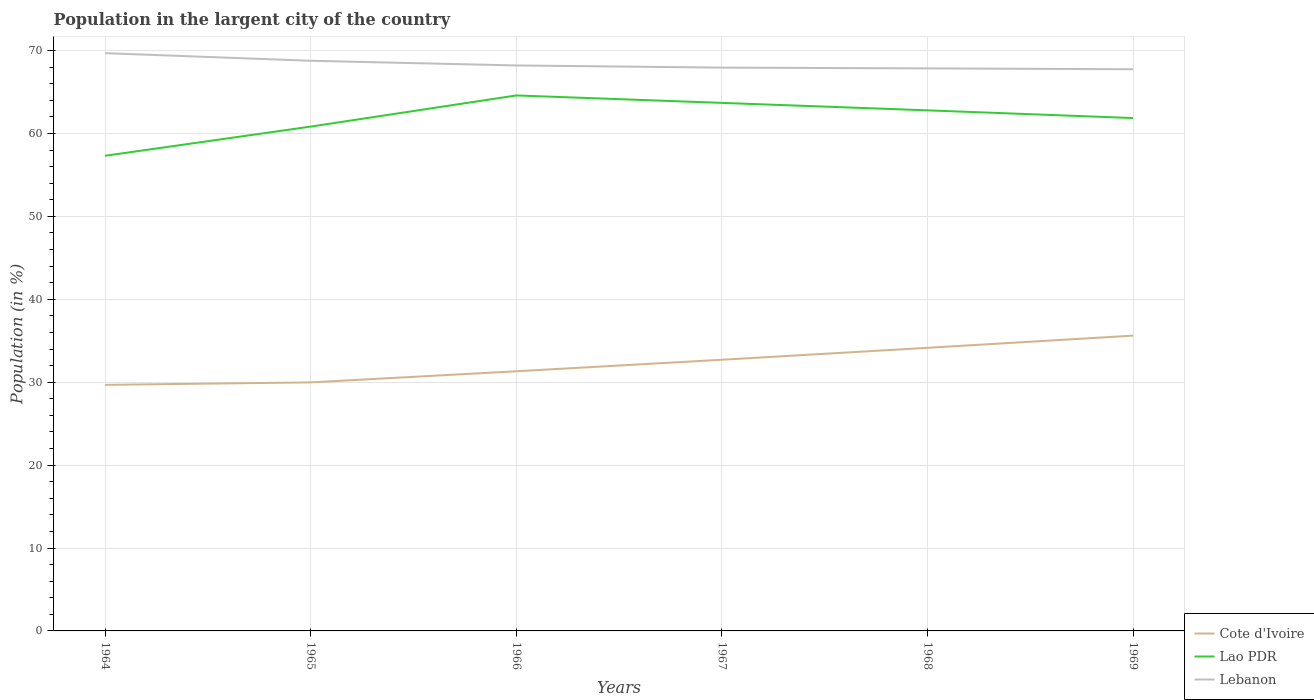Across all years, what is the maximum percentage of population in the largent city in Cote d'Ivoire?
Your answer should be compact. 29.68. In which year was the percentage of population in the largent city in Lebanon maximum?
Your answer should be compact. 1969. What is the total percentage of population in the largent city in Lao PDR in the graph?
Keep it short and to the point. -1.03. What is the difference between the highest and the second highest percentage of population in the largent city in Lao PDR?
Keep it short and to the point. 7.28. Is the percentage of population in the largent city in Lebanon strictly greater than the percentage of population in the largent city in Lao PDR over the years?
Offer a terse response. No. How many lines are there?
Your response must be concise. 3. How many years are there in the graph?
Make the answer very short. 6. Are the values on the major ticks of Y-axis written in scientific E-notation?
Your answer should be compact. No. How are the legend labels stacked?
Your answer should be very brief. Vertical. What is the title of the graph?
Your answer should be very brief. Population in the largent city of the country. What is the label or title of the X-axis?
Provide a succinct answer. Years. What is the label or title of the Y-axis?
Your answer should be very brief. Population (in %). What is the Population (in %) in Cote d'Ivoire in 1964?
Provide a short and direct response. 29.68. What is the Population (in %) of Lao PDR in 1964?
Your answer should be very brief. 57.31. What is the Population (in %) of Lebanon in 1964?
Keep it short and to the point. 69.69. What is the Population (in %) in Cote d'Ivoire in 1965?
Your answer should be very brief. 29.98. What is the Population (in %) in Lao PDR in 1965?
Provide a succinct answer. 60.84. What is the Population (in %) in Lebanon in 1965?
Your answer should be compact. 68.77. What is the Population (in %) of Cote d'Ivoire in 1966?
Offer a terse response. 31.32. What is the Population (in %) of Lao PDR in 1966?
Your answer should be compact. 64.59. What is the Population (in %) of Lebanon in 1966?
Provide a succinct answer. 68.21. What is the Population (in %) in Cote d'Ivoire in 1967?
Your answer should be compact. 32.71. What is the Population (in %) of Lao PDR in 1967?
Your answer should be compact. 63.69. What is the Population (in %) in Lebanon in 1967?
Offer a very short reply. 67.95. What is the Population (in %) of Cote d'Ivoire in 1968?
Offer a very short reply. 34.15. What is the Population (in %) of Lao PDR in 1968?
Provide a short and direct response. 62.79. What is the Population (in %) in Lebanon in 1968?
Give a very brief answer. 67.86. What is the Population (in %) in Cote d'Ivoire in 1969?
Provide a short and direct response. 35.62. What is the Population (in %) in Lao PDR in 1969?
Offer a very short reply. 61.86. What is the Population (in %) of Lebanon in 1969?
Ensure brevity in your answer.  67.75. Across all years, what is the maximum Population (in %) of Cote d'Ivoire?
Ensure brevity in your answer.  35.62. Across all years, what is the maximum Population (in %) in Lao PDR?
Provide a succinct answer. 64.59. Across all years, what is the maximum Population (in %) in Lebanon?
Your response must be concise. 69.69. Across all years, what is the minimum Population (in %) in Cote d'Ivoire?
Your answer should be very brief. 29.68. Across all years, what is the minimum Population (in %) in Lao PDR?
Make the answer very short. 57.31. Across all years, what is the minimum Population (in %) of Lebanon?
Your answer should be very brief. 67.75. What is the total Population (in %) in Cote d'Ivoire in the graph?
Your response must be concise. 193.46. What is the total Population (in %) in Lao PDR in the graph?
Give a very brief answer. 371.1. What is the total Population (in %) in Lebanon in the graph?
Ensure brevity in your answer.  410.23. What is the difference between the Population (in %) of Cote d'Ivoire in 1964 and that in 1965?
Provide a succinct answer. -0.3. What is the difference between the Population (in %) in Lao PDR in 1964 and that in 1965?
Keep it short and to the point. -3.52. What is the difference between the Population (in %) of Lebanon in 1964 and that in 1965?
Your answer should be compact. 0.92. What is the difference between the Population (in %) of Cote d'Ivoire in 1964 and that in 1966?
Offer a very short reply. -1.64. What is the difference between the Population (in %) in Lao PDR in 1964 and that in 1966?
Provide a short and direct response. -7.28. What is the difference between the Population (in %) in Lebanon in 1964 and that in 1966?
Your answer should be very brief. 1.48. What is the difference between the Population (in %) of Cote d'Ivoire in 1964 and that in 1967?
Offer a terse response. -3.03. What is the difference between the Population (in %) in Lao PDR in 1964 and that in 1967?
Your answer should be very brief. -6.38. What is the difference between the Population (in %) of Lebanon in 1964 and that in 1967?
Offer a very short reply. 1.74. What is the difference between the Population (in %) in Cote d'Ivoire in 1964 and that in 1968?
Provide a short and direct response. -4.47. What is the difference between the Population (in %) of Lao PDR in 1964 and that in 1968?
Your answer should be very brief. -5.48. What is the difference between the Population (in %) in Lebanon in 1964 and that in 1968?
Give a very brief answer. 1.84. What is the difference between the Population (in %) in Cote d'Ivoire in 1964 and that in 1969?
Make the answer very short. -5.94. What is the difference between the Population (in %) of Lao PDR in 1964 and that in 1969?
Your answer should be compact. -4.55. What is the difference between the Population (in %) of Lebanon in 1964 and that in 1969?
Provide a short and direct response. 1.94. What is the difference between the Population (in %) in Cote d'Ivoire in 1965 and that in 1966?
Give a very brief answer. -1.34. What is the difference between the Population (in %) in Lao PDR in 1965 and that in 1966?
Give a very brief answer. -3.76. What is the difference between the Population (in %) in Lebanon in 1965 and that in 1966?
Make the answer very short. 0.57. What is the difference between the Population (in %) of Cote d'Ivoire in 1965 and that in 1967?
Your answer should be compact. -2.73. What is the difference between the Population (in %) in Lao PDR in 1965 and that in 1967?
Your answer should be compact. -2.86. What is the difference between the Population (in %) of Lebanon in 1965 and that in 1967?
Your answer should be compact. 0.83. What is the difference between the Population (in %) in Cote d'Ivoire in 1965 and that in 1968?
Ensure brevity in your answer.  -4.17. What is the difference between the Population (in %) in Lao PDR in 1965 and that in 1968?
Offer a terse response. -1.96. What is the difference between the Population (in %) in Lebanon in 1965 and that in 1968?
Make the answer very short. 0.92. What is the difference between the Population (in %) in Cote d'Ivoire in 1965 and that in 1969?
Give a very brief answer. -5.64. What is the difference between the Population (in %) in Lao PDR in 1965 and that in 1969?
Keep it short and to the point. -1.03. What is the difference between the Population (in %) in Lebanon in 1965 and that in 1969?
Your answer should be compact. 1.02. What is the difference between the Population (in %) of Cote d'Ivoire in 1966 and that in 1967?
Your answer should be very brief. -1.39. What is the difference between the Population (in %) in Lao PDR in 1966 and that in 1967?
Provide a short and direct response. 0.9. What is the difference between the Population (in %) in Lebanon in 1966 and that in 1967?
Your answer should be compact. 0.26. What is the difference between the Population (in %) of Cote d'Ivoire in 1966 and that in 1968?
Give a very brief answer. -2.83. What is the difference between the Population (in %) of Lao PDR in 1966 and that in 1968?
Your response must be concise. 1.8. What is the difference between the Population (in %) in Lebanon in 1966 and that in 1968?
Make the answer very short. 0.35. What is the difference between the Population (in %) of Cote d'Ivoire in 1966 and that in 1969?
Provide a succinct answer. -4.3. What is the difference between the Population (in %) in Lao PDR in 1966 and that in 1969?
Offer a terse response. 2.73. What is the difference between the Population (in %) in Lebanon in 1966 and that in 1969?
Give a very brief answer. 0.46. What is the difference between the Population (in %) in Cote d'Ivoire in 1967 and that in 1968?
Your answer should be very brief. -1.44. What is the difference between the Population (in %) of Lao PDR in 1967 and that in 1968?
Provide a succinct answer. 0.9. What is the difference between the Population (in %) in Lebanon in 1967 and that in 1968?
Offer a terse response. 0.09. What is the difference between the Population (in %) in Cote d'Ivoire in 1967 and that in 1969?
Your answer should be compact. -2.91. What is the difference between the Population (in %) in Lao PDR in 1967 and that in 1969?
Your response must be concise. 1.83. What is the difference between the Population (in %) of Lebanon in 1967 and that in 1969?
Your response must be concise. 0.2. What is the difference between the Population (in %) of Cote d'Ivoire in 1968 and that in 1969?
Your response must be concise. -1.47. What is the difference between the Population (in %) in Lao PDR in 1968 and that in 1969?
Make the answer very short. 0.93. What is the difference between the Population (in %) in Lebanon in 1968 and that in 1969?
Offer a terse response. 0.1. What is the difference between the Population (in %) in Cote d'Ivoire in 1964 and the Population (in %) in Lao PDR in 1965?
Your response must be concise. -31.15. What is the difference between the Population (in %) in Cote d'Ivoire in 1964 and the Population (in %) in Lebanon in 1965?
Your response must be concise. -39.09. What is the difference between the Population (in %) of Lao PDR in 1964 and the Population (in %) of Lebanon in 1965?
Provide a succinct answer. -11.46. What is the difference between the Population (in %) of Cote d'Ivoire in 1964 and the Population (in %) of Lao PDR in 1966?
Ensure brevity in your answer.  -34.91. What is the difference between the Population (in %) of Cote d'Ivoire in 1964 and the Population (in %) of Lebanon in 1966?
Your answer should be compact. -38.53. What is the difference between the Population (in %) in Lao PDR in 1964 and the Population (in %) in Lebanon in 1966?
Your answer should be compact. -10.9. What is the difference between the Population (in %) of Cote d'Ivoire in 1964 and the Population (in %) of Lao PDR in 1967?
Your answer should be very brief. -34.01. What is the difference between the Population (in %) of Cote d'Ivoire in 1964 and the Population (in %) of Lebanon in 1967?
Provide a succinct answer. -38.27. What is the difference between the Population (in %) of Lao PDR in 1964 and the Population (in %) of Lebanon in 1967?
Keep it short and to the point. -10.63. What is the difference between the Population (in %) in Cote d'Ivoire in 1964 and the Population (in %) in Lao PDR in 1968?
Offer a very short reply. -33.11. What is the difference between the Population (in %) in Cote d'Ivoire in 1964 and the Population (in %) in Lebanon in 1968?
Give a very brief answer. -38.17. What is the difference between the Population (in %) of Lao PDR in 1964 and the Population (in %) of Lebanon in 1968?
Ensure brevity in your answer.  -10.54. What is the difference between the Population (in %) of Cote d'Ivoire in 1964 and the Population (in %) of Lao PDR in 1969?
Your response must be concise. -32.18. What is the difference between the Population (in %) of Cote d'Ivoire in 1964 and the Population (in %) of Lebanon in 1969?
Offer a very short reply. -38.07. What is the difference between the Population (in %) in Lao PDR in 1964 and the Population (in %) in Lebanon in 1969?
Offer a terse response. -10.44. What is the difference between the Population (in %) in Cote d'Ivoire in 1965 and the Population (in %) in Lao PDR in 1966?
Give a very brief answer. -34.61. What is the difference between the Population (in %) of Cote d'Ivoire in 1965 and the Population (in %) of Lebanon in 1966?
Provide a succinct answer. -38.23. What is the difference between the Population (in %) of Lao PDR in 1965 and the Population (in %) of Lebanon in 1966?
Your response must be concise. -7.37. What is the difference between the Population (in %) in Cote d'Ivoire in 1965 and the Population (in %) in Lao PDR in 1967?
Offer a terse response. -33.72. What is the difference between the Population (in %) in Cote d'Ivoire in 1965 and the Population (in %) in Lebanon in 1967?
Ensure brevity in your answer.  -37.97. What is the difference between the Population (in %) in Lao PDR in 1965 and the Population (in %) in Lebanon in 1967?
Provide a succinct answer. -7.11. What is the difference between the Population (in %) of Cote d'Ivoire in 1965 and the Population (in %) of Lao PDR in 1968?
Provide a short and direct response. -32.82. What is the difference between the Population (in %) in Cote d'Ivoire in 1965 and the Population (in %) in Lebanon in 1968?
Make the answer very short. -37.88. What is the difference between the Population (in %) of Lao PDR in 1965 and the Population (in %) of Lebanon in 1968?
Keep it short and to the point. -7.02. What is the difference between the Population (in %) of Cote d'Ivoire in 1965 and the Population (in %) of Lao PDR in 1969?
Provide a succinct answer. -31.89. What is the difference between the Population (in %) of Cote d'Ivoire in 1965 and the Population (in %) of Lebanon in 1969?
Your response must be concise. -37.77. What is the difference between the Population (in %) in Lao PDR in 1965 and the Population (in %) in Lebanon in 1969?
Offer a very short reply. -6.92. What is the difference between the Population (in %) in Cote d'Ivoire in 1966 and the Population (in %) in Lao PDR in 1967?
Your answer should be very brief. -32.37. What is the difference between the Population (in %) in Cote d'Ivoire in 1966 and the Population (in %) in Lebanon in 1967?
Ensure brevity in your answer.  -36.63. What is the difference between the Population (in %) in Lao PDR in 1966 and the Population (in %) in Lebanon in 1967?
Provide a short and direct response. -3.36. What is the difference between the Population (in %) in Cote d'Ivoire in 1966 and the Population (in %) in Lao PDR in 1968?
Give a very brief answer. -31.47. What is the difference between the Population (in %) of Cote d'Ivoire in 1966 and the Population (in %) of Lebanon in 1968?
Offer a very short reply. -36.53. What is the difference between the Population (in %) in Lao PDR in 1966 and the Population (in %) in Lebanon in 1968?
Give a very brief answer. -3.26. What is the difference between the Population (in %) of Cote d'Ivoire in 1966 and the Population (in %) of Lao PDR in 1969?
Provide a succinct answer. -30.54. What is the difference between the Population (in %) of Cote d'Ivoire in 1966 and the Population (in %) of Lebanon in 1969?
Your answer should be very brief. -36.43. What is the difference between the Population (in %) in Lao PDR in 1966 and the Population (in %) in Lebanon in 1969?
Give a very brief answer. -3.16. What is the difference between the Population (in %) of Cote d'Ivoire in 1967 and the Population (in %) of Lao PDR in 1968?
Provide a short and direct response. -30.08. What is the difference between the Population (in %) in Cote d'Ivoire in 1967 and the Population (in %) in Lebanon in 1968?
Offer a very short reply. -35.15. What is the difference between the Population (in %) in Lao PDR in 1967 and the Population (in %) in Lebanon in 1968?
Keep it short and to the point. -4.16. What is the difference between the Population (in %) in Cote d'Ivoire in 1967 and the Population (in %) in Lao PDR in 1969?
Offer a terse response. -29.15. What is the difference between the Population (in %) of Cote d'Ivoire in 1967 and the Population (in %) of Lebanon in 1969?
Your answer should be very brief. -35.04. What is the difference between the Population (in %) of Lao PDR in 1967 and the Population (in %) of Lebanon in 1969?
Your answer should be compact. -4.06. What is the difference between the Population (in %) of Cote d'Ivoire in 1968 and the Population (in %) of Lao PDR in 1969?
Provide a short and direct response. -27.71. What is the difference between the Population (in %) of Cote d'Ivoire in 1968 and the Population (in %) of Lebanon in 1969?
Your answer should be compact. -33.6. What is the difference between the Population (in %) in Lao PDR in 1968 and the Population (in %) in Lebanon in 1969?
Offer a terse response. -4.96. What is the average Population (in %) in Cote d'Ivoire per year?
Your answer should be compact. 32.24. What is the average Population (in %) in Lao PDR per year?
Your response must be concise. 61.85. What is the average Population (in %) in Lebanon per year?
Your answer should be very brief. 68.37. In the year 1964, what is the difference between the Population (in %) in Cote d'Ivoire and Population (in %) in Lao PDR?
Offer a terse response. -27.63. In the year 1964, what is the difference between the Population (in %) in Cote d'Ivoire and Population (in %) in Lebanon?
Offer a terse response. -40.01. In the year 1964, what is the difference between the Population (in %) of Lao PDR and Population (in %) of Lebanon?
Make the answer very short. -12.38. In the year 1965, what is the difference between the Population (in %) in Cote d'Ivoire and Population (in %) in Lao PDR?
Keep it short and to the point. -30.86. In the year 1965, what is the difference between the Population (in %) in Cote d'Ivoire and Population (in %) in Lebanon?
Your answer should be very brief. -38.8. In the year 1965, what is the difference between the Population (in %) in Lao PDR and Population (in %) in Lebanon?
Offer a terse response. -7.94. In the year 1966, what is the difference between the Population (in %) of Cote d'Ivoire and Population (in %) of Lao PDR?
Provide a succinct answer. -33.27. In the year 1966, what is the difference between the Population (in %) of Cote d'Ivoire and Population (in %) of Lebanon?
Your answer should be very brief. -36.89. In the year 1966, what is the difference between the Population (in %) of Lao PDR and Population (in %) of Lebanon?
Your answer should be compact. -3.62. In the year 1967, what is the difference between the Population (in %) in Cote d'Ivoire and Population (in %) in Lao PDR?
Ensure brevity in your answer.  -30.98. In the year 1967, what is the difference between the Population (in %) of Cote d'Ivoire and Population (in %) of Lebanon?
Offer a terse response. -35.24. In the year 1967, what is the difference between the Population (in %) of Lao PDR and Population (in %) of Lebanon?
Keep it short and to the point. -4.25. In the year 1968, what is the difference between the Population (in %) of Cote d'Ivoire and Population (in %) of Lao PDR?
Make the answer very short. -28.65. In the year 1968, what is the difference between the Population (in %) of Cote d'Ivoire and Population (in %) of Lebanon?
Offer a very short reply. -33.71. In the year 1968, what is the difference between the Population (in %) of Lao PDR and Population (in %) of Lebanon?
Give a very brief answer. -5.06. In the year 1969, what is the difference between the Population (in %) of Cote d'Ivoire and Population (in %) of Lao PDR?
Provide a short and direct response. -26.24. In the year 1969, what is the difference between the Population (in %) in Cote d'Ivoire and Population (in %) in Lebanon?
Your answer should be very brief. -32.13. In the year 1969, what is the difference between the Population (in %) of Lao PDR and Population (in %) of Lebanon?
Give a very brief answer. -5.89. What is the ratio of the Population (in %) of Cote d'Ivoire in 1964 to that in 1965?
Make the answer very short. 0.99. What is the ratio of the Population (in %) of Lao PDR in 1964 to that in 1965?
Offer a very short reply. 0.94. What is the ratio of the Population (in %) of Lebanon in 1964 to that in 1965?
Your answer should be very brief. 1.01. What is the ratio of the Population (in %) of Cote d'Ivoire in 1964 to that in 1966?
Give a very brief answer. 0.95. What is the ratio of the Population (in %) of Lao PDR in 1964 to that in 1966?
Your answer should be compact. 0.89. What is the ratio of the Population (in %) in Lebanon in 1964 to that in 1966?
Offer a very short reply. 1.02. What is the ratio of the Population (in %) in Cote d'Ivoire in 1964 to that in 1967?
Make the answer very short. 0.91. What is the ratio of the Population (in %) of Lao PDR in 1964 to that in 1967?
Your answer should be very brief. 0.9. What is the ratio of the Population (in %) of Lebanon in 1964 to that in 1967?
Offer a very short reply. 1.03. What is the ratio of the Population (in %) in Cote d'Ivoire in 1964 to that in 1968?
Keep it short and to the point. 0.87. What is the ratio of the Population (in %) of Lao PDR in 1964 to that in 1968?
Offer a terse response. 0.91. What is the ratio of the Population (in %) of Lebanon in 1964 to that in 1968?
Your answer should be compact. 1.03. What is the ratio of the Population (in %) in Lao PDR in 1964 to that in 1969?
Offer a very short reply. 0.93. What is the ratio of the Population (in %) of Lebanon in 1964 to that in 1969?
Make the answer very short. 1.03. What is the ratio of the Population (in %) of Cote d'Ivoire in 1965 to that in 1966?
Provide a succinct answer. 0.96. What is the ratio of the Population (in %) in Lao PDR in 1965 to that in 1966?
Provide a succinct answer. 0.94. What is the ratio of the Population (in %) of Lebanon in 1965 to that in 1966?
Your response must be concise. 1.01. What is the ratio of the Population (in %) of Cote d'Ivoire in 1965 to that in 1967?
Provide a succinct answer. 0.92. What is the ratio of the Population (in %) of Lao PDR in 1965 to that in 1967?
Make the answer very short. 0.96. What is the ratio of the Population (in %) of Lebanon in 1965 to that in 1967?
Give a very brief answer. 1.01. What is the ratio of the Population (in %) in Cote d'Ivoire in 1965 to that in 1968?
Provide a short and direct response. 0.88. What is the ratio of the Population (in %) in Lao PDR in 1965 to that in 1968?
Offer a very short reply. 0.97. What is the ratio of the Population (in %) of Lebanon in 1965 to that in 1968?
Give a very brief answer. 1.01. What is the ratio of the Population (in %) in Cote d'Ivoire in 1965 to that in 1969?
Your answer should be compact. 0.84. What is the ratio of the Population (in %) in Lao PDR in 1965 to that in 1969?
Give a very brief answer. 0.98. What is the ratio of the Population (in %) in Lebanon in 1965 to that in 1969?
Provide a short and direct response. 1.02. What is the ratio of the Population (in %) of Cote d'Ivoire in 1966 to that in 1967?
Your response must be concise. 0.96. What is the ratio of the Population (in %) in Lao PDR in 1966 to that in 1967?
Offer a terse response. 1.01. What is the ratio of the Population (in %) of Lebanon in 1966 to that in 1967?
Your answer should be compact. 1. What is the ratio of the Population (in %) of Cote d'Ivoire in 1966 to that in 1968?
Offer a terse response. 0.92. What is the ratio of the Population (in %) in Lao PDR in 1966 to that in 1968?
Ensure brevity in your answer.  1.03. What is the ratio of the Population (in %) in Cote d'Ivoire in 1966 to that in 1969?
Keep it short and to the point. 0.88. What is the ratio of the Population (in %) of Lao PDR in 1966 to that in 1969?
Your response must be concise. 1.04. What is the ratio of the Population (in %) of Lebanon in 1966 to that in 1969?
Your answer should be very brief. 1.01. What is the ratio of the Population (in %) in Cote d'Ivoire in 1967 to that in 1968?
Your answer should be very brief. 0.96. What is the ratio of the Population (in %) in Lao PDR in 1967 to that in 1968?
Provide a succinct answer. 1.01. What is the ratio of the Population (in %) in Cote d'Ivoire in 1967 to that in 1969?
Give a very brief answer. 0.92. What is the ratio of the Population (in %) in Lao PDR in 1967 to that in 1969?
Offer a terse response. 1.03. What is the ratio of the Population (in %) in Lebanon in 1967 to that in 1969?
Provide a succinct answer. 1. What is the ratio of the Population (in %) of Cote d'Ivoire in 1968 to that in 1969?
Provide a succinct answer. 0.96. What is the ratio of the Population (in %) of Lao PDR in 1968 to that in 1969?
Offer a very short reply. 1.01. What is the difference between the highest and the second highest Population (in %) of Cote d'Ivoire?
Your response must be concise. 1.47. What is the difference between the highest and the second highest Population (in %) in Lao PDR?
Your response must be concise. 0.9. What is the difference between the highest and the second highest Population (in %) in Lebanon?
Offer a terse response. 0.92. What is the difference between the highest and the lowest Population (in %) in Cote d'Ivoire?
Your answer should be very brief. 5.94. What is the difference between the highest and the lowest Population (in %) in Lao PDR?
Your response must be concise. 7.28. What is the difference between the highest and the lowest Population (in %) in Lebanon?
Make the answer very short. 1.94. 